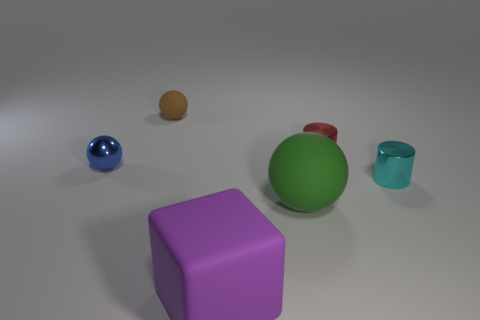Are there any other things that are the same color as the large rubber cube?
Your response must be concise. No. There is a rubber cube in front of the big green matte object; how big is it?
Give a very brief answer. Large. How many other objects are there of the same material as the red cylinder?
Offer a very short reply. 2. Are there more tiny red cylinders than things?
Provide a succinct answer. No. What is the color of the small metallic sphere?
Your answer should be very brief. Blue. Are there any large purple matte things right of the cylinder that is in front of the small red metal cylinder?
Provide a succinct answer. No. There is a metal object that is left of the big object that is behind the large purple matte block; what shape is it?
Provide a succinct answer. Sphere. Is the number of tiny brown rubber objects less than the number of large green matte cylinders?
Provide a succinct answer. No. Do the red thing and the small blue ball have the same material?
Your answer should be very brief. Yes. There is a metal object that is both to the right of the cube and in front of the red cylinder; what is its color?
Keep it short and to the point. Cyan. 